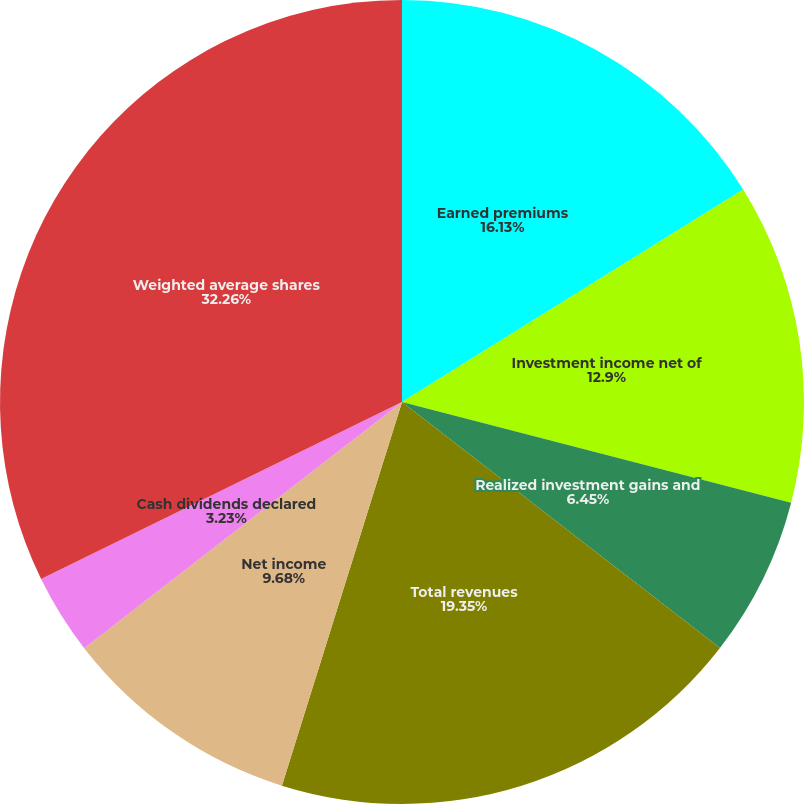Convert chart. <chart><loc_0><loc_0><loc_500><loc_500><pie_chart><fcel>Earned premiums<fcel>Investment income net of<fcel>Realized investment gains and<fcel>Total revenues<fcel>Net income<fcel>Net income - diluted<fcel>Cash dividends declared<fcel>Weighted average shares<nl><fcel>16.13%<fcel>12.9%<fcel>6.45%<fcel>19.35%<fcel>9.68%<fcel>0.0%<fcel>3.23%<fcel>32.26%<nl></chart> 